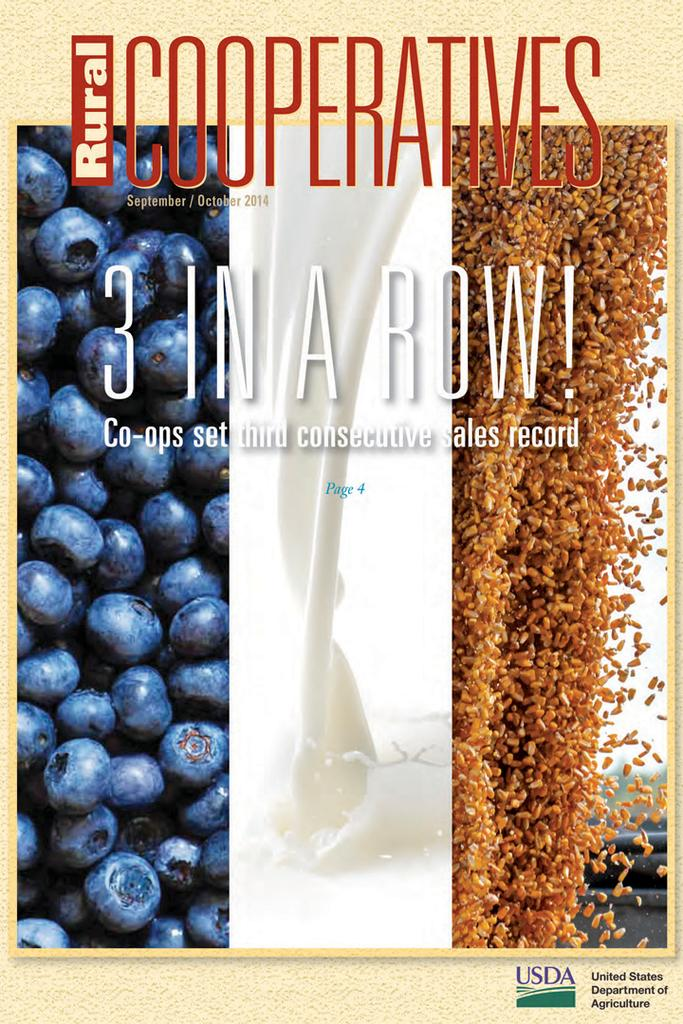<image>
Offer a succinct explanation of the picture presented. Rural Cooperatives' September/October 2014 issue featured co-ops setting third consecutive sales record. 